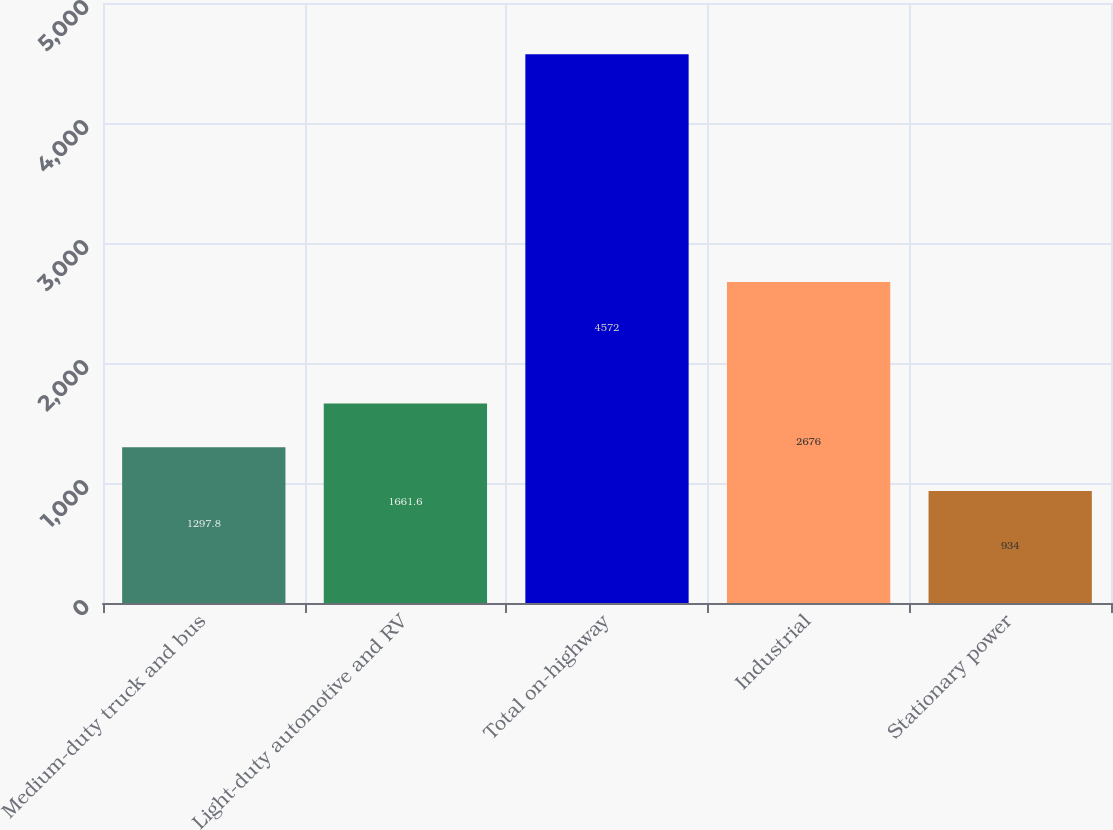Convert chart to OTSL. <chart><loc_0><loc_0><loc_500><loc_500><bar_chart><fcel>Medium-duty truck and bus<fcel>Light-duty automotive and RV<fcel>Total on-highway<fcel>Industrial<fcel>Stationary power<nl><fcel>1297.8<fcel>1661.6<fcel>4572<fcel>2676<fcel>934<nl></chart> 